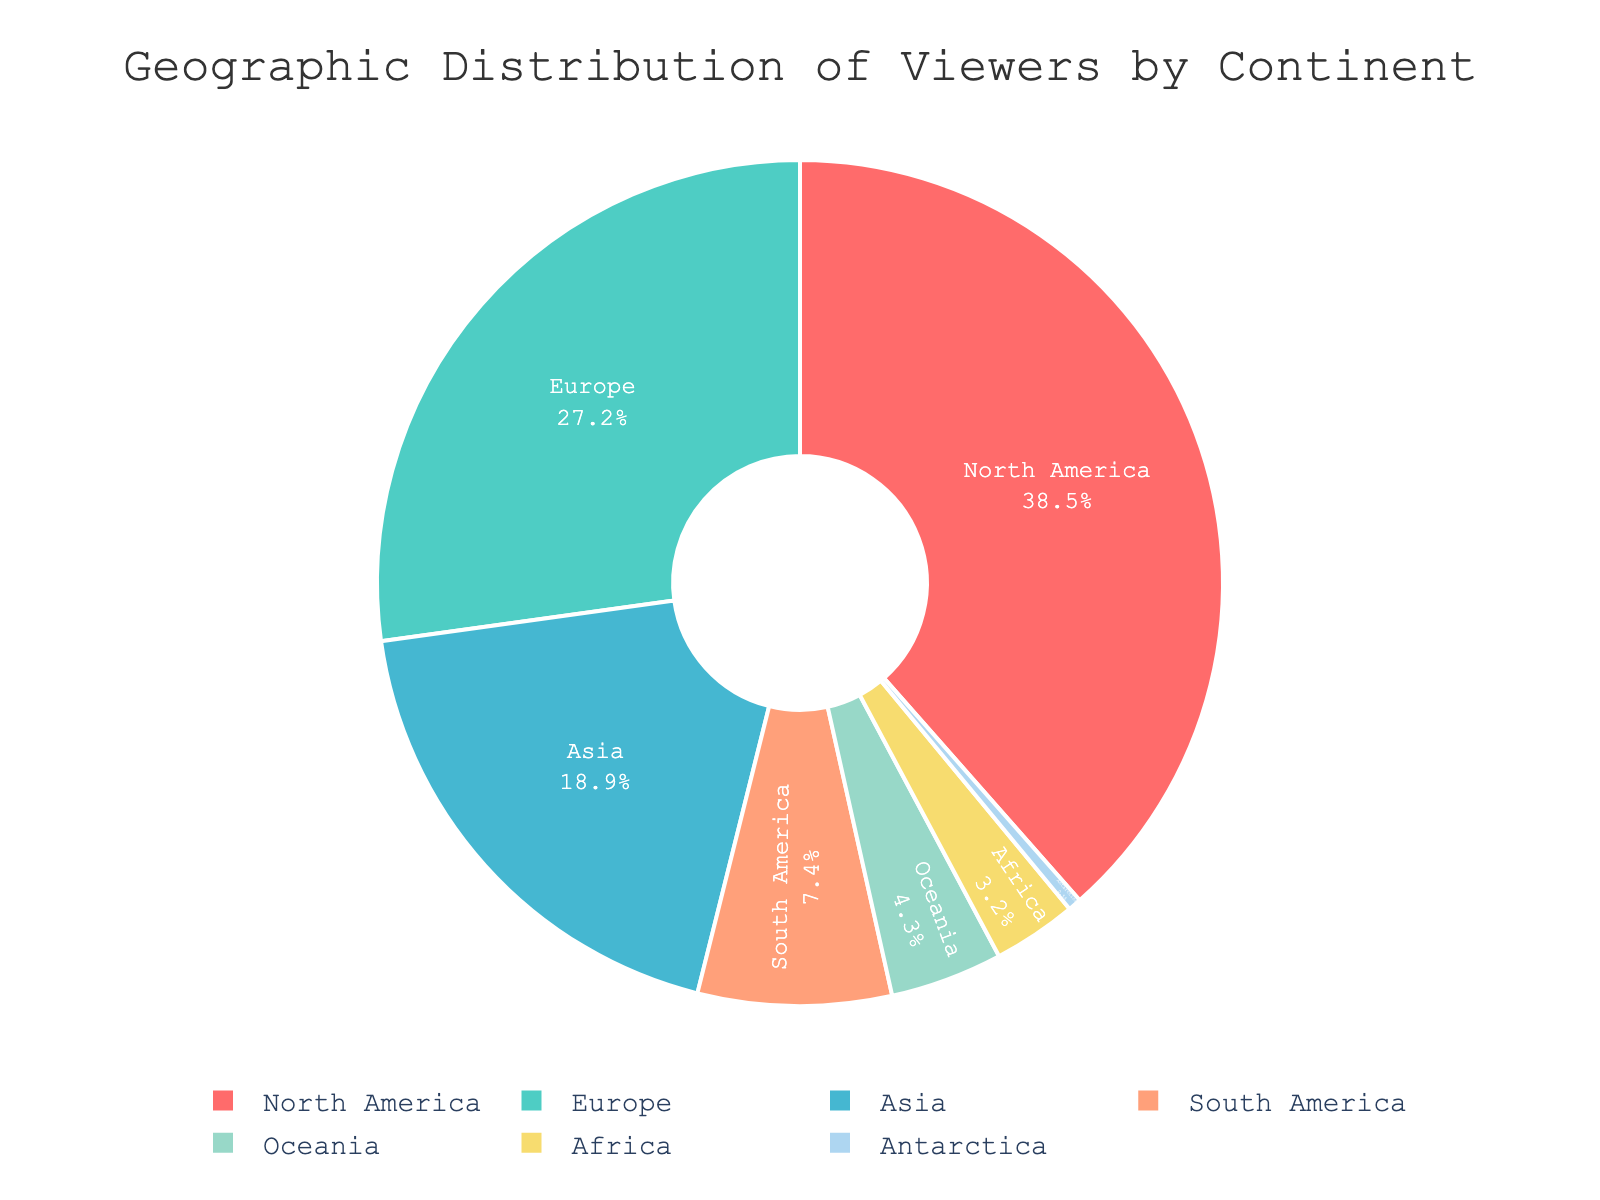What percentage of viewers come from North America? By looking at the figure, we can see the segment representing North America and the text inside it showing the percentage.
Answer: 38.5% Which continent contributes the smallest percentage of viewers? From the pie chart, the smallest segment by both size and labeled percentage is Antarctica.
Answer: Antarctica How does the percentage of viewers from Asia compare to those from Europe? We can look at the labels for both Asia and Europe on the pie chart. Asia has 18.9% while Europe has 27.2%. Since 27.2% is higher than 18.9%, Europe has a higher percentage of viewers.
Answer: Europe has more viewers than Asia What is the combined percentage of viewers from South America and Africa? The chart shows South America with 7.4% and Africa with 3.2%. Adding these together gives 7.4% + 3.2% = 10.6%.
Answer: 10.6% What is the difference in viewership percentage between North America and Oceania? By checking the chart, North America has 38.5% and Oceania has 4.3%. The difference is 38.5% - 4.3% = 34.2%.
Answer: 34.2% Which continent has a viewer percentage just below 5%? From the chart, the segment with slightly less than 5% is Oceania, which is labeled as 4.3%.
Answer: Oceania Which two continents' viewer percentages add up to over 50%? By examining the chart, North America with 38.5% and Europe with 27.2% together sum to 38.5% + 27.2% = 65.7%, which is over 50%.
Answer: North America and Europe Which segment is visually represented in yellow and what percentage does it have? Observing the pie chart, the yellow segment represents viewers from  South America with a percentage of 7.4%.
Answer: South America, 7.4% Is the viewer percentage from Africa greater or less than the viewer percentage from Oceania? From the chart, Africa has 3.2% and Oceania has 4.3%. Since 3.2% is less than 4.3%, Africa's viewer percentage is less.
Answer: Less What is the average percentage of viewers from the continents not contributing the largest or smallest percentages? Excluding North America (38.5%) and Antarctica (0.5%), we have Europe (27.2%), Asia (18.9%), South America (7.4%), Oceania (4.3%), and Africa (3.2%). The average is (27.2 + 18.9 + 7.4 + 4.3 + 3.2) / 5 = 12.2%.
Answer: 12.2% 